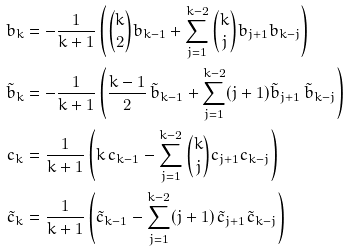Convert formula to latex. <formula><loc_0><loc_0><loc_500><loc_500>b _ { k } & = - \frac { 1 } { k + 1 } \left ( \binom { k } { 2 } b _ { k - 1 } + \sum _ { j = 1 } ^ { k - 2 } \binom { k } { j } b _ { j + 1 } b _ { k - j } \right ) \\ \tilde { b } _ { k } & = - \frac { 1 } { k + 1 } \left ( \frac { k - 1 } { 2 } \, \tilde { b } _ { k - 1 } + \sum _ { j = 1 } ^ { k - 2 } ( j + 1 ) \tilde { b } _ { j + 1 } \, \tilde { b } _ { k - j } \right ) \\ c _ { k } & = \frac { 1 } { k + 1 } \left ( k \, c _ { k - 1 } - \sum _ { j = 1 } ^ { k - 2 } \binom { k } { j } c _ { j + 1 } c _ { k - j } \right ) \\ \tilde { c } _ { k } & = \frac { 1 } { k + 1 } \left ( \tilde { c } _ { k - 1 } - \sum _ { j = 1 } ^ { k - 2 } ( j + 1 ) \, \tilde { c } _ { j + 1 } \tilde { c } _ { k - j } \right )</formula> 